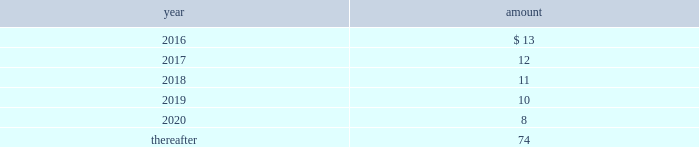Long-term liabilities .
The value of the company 2019s deferred compensation obligations is based on the market value of the participants 2019 notional investment accounts .
The notional investments are comprised primarily of mutual funds , which are based on observable market prices .
Mark-to-market derivative asset and liability 2014the company utilizes fixed-to-floating interest-rate swaps , typically designated as fair-value hedges , to achieve a targeted level of variable-rate debt as a percentage of total debt .
The company also employs derivative financial instruments in the form of variable-to-fixed interest rate swaps , classified as economic hedges , in order to fix the interest cost on some of its variable-rate debt .
The company uses a calculation of future cash inflows and estimated future outflows , which are discounted , to determine the current fair value .
Additional inputs to the present value calculation include the contract terms , counterparty credit risk , interest rates and market volatility .
Other investments 2014other investments primarily represent money market funds used for active employee benefits .
The company includes other investments in other current assets .
Note 18 : leases the company has entered into operating leases involving certain facilities and equipment .
Rental expenses under operating leases were $ 21 for 2015 , $ 22 for 2014 and $ 23 for 2013 .
The operating leases for facilities will expire over the next 25 years and the operating leases for equipment will expire over the next five years .
Certain operating leases have renewal options ranging from one to five years .
The minimum annual future rental commitment under operating leases that have initial or remaining non- cancelable lease terms over the next five years and thereafter are as follows: .
The company has a series of agreements with various public entities ( the 201cpartners 201d ) to establish certain joint ventures , commonly referred to as 201cpublic-private partnerships . 201d under the public-private partnerships , the company constructed utility plant , financed by the company and the partners constructed utility plant ( connected to the company 2019s property ) , financed by the partners .
The company agreed to transfer and convey some of its real and personal property to the partners in exchange for an equal principal amount of industrial development bonds ( 201cidbs 201d ) , issued by the partners under a state industrial development bond and commercial development act .
The company leased back the total facilities , including portions funded by both the company and the partners , under leases for a period of 40 years .
The leases related to the portion of the facilities funded by the company have required payments from the company to the partners that approximate the payments required by the terms of the idbs from the partners to the company ( as the holder of the idbs ) .
As the ownership of the portion of the facilities constructed by the company will revert back to the company at the end of the lease , the company has recorded these as capital leases .
The lease obligation and the receivable for the principal amount of the idbs are presented by the company on a net basis .
The gross cost of the facilities funded by the company recognized as a capital lease asset was $ 156 and $ 157 as of december 31 , 2015 and 2014 , respectively , which is presented in property , plant and equipment in the accompanying consolidated balance sheets .
The future payments under the lease obligations are equal to and offset by the payments receivable under the idbs. .
What percentage does rental expense make up of gross cost of facilities funded in 2014? 
Computations: (22 / 157)
Answer: 0.14013. 